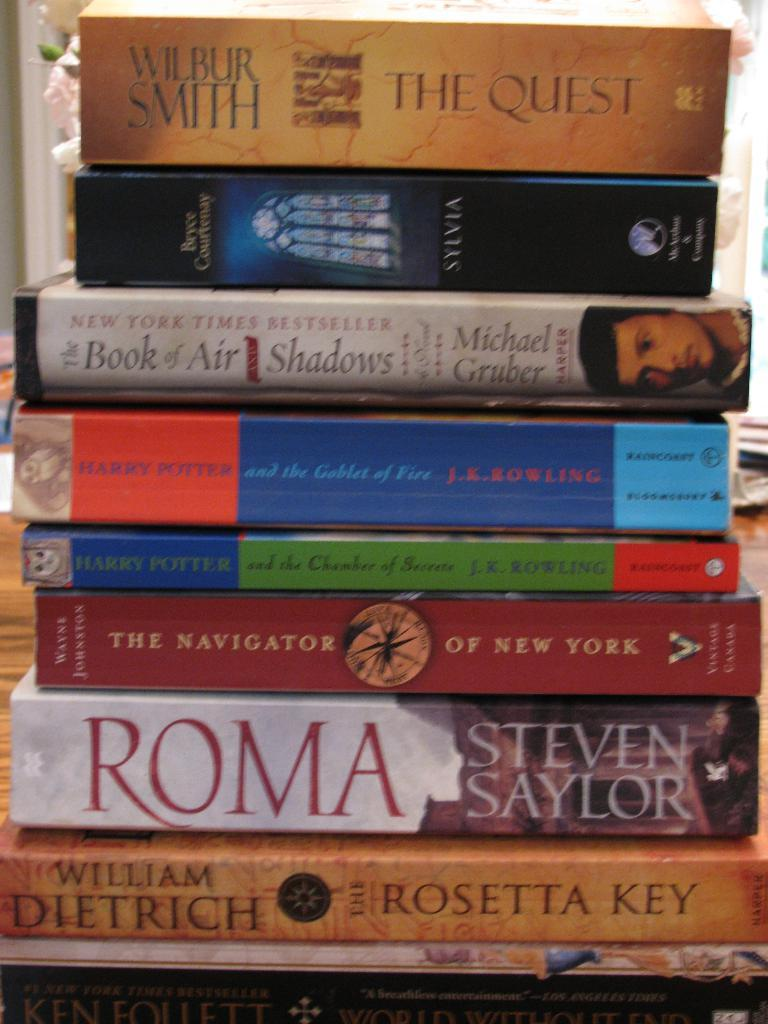<image>
Relay a brief, clear account of the picture shown. a stack of books with the  Quest by Wilbur Smith on top 